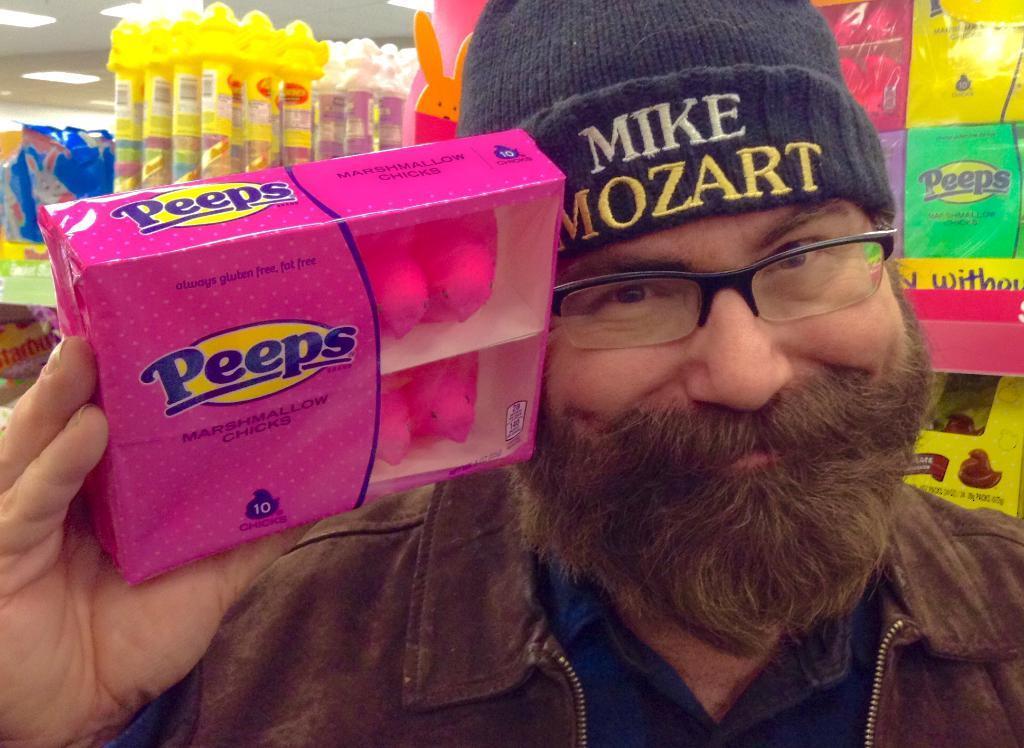How would you summarize this image in a sentence or two? In this picture we can see a person holding a box in his hands. We can see a few boxes in the racks. Some lights are visible on top. 